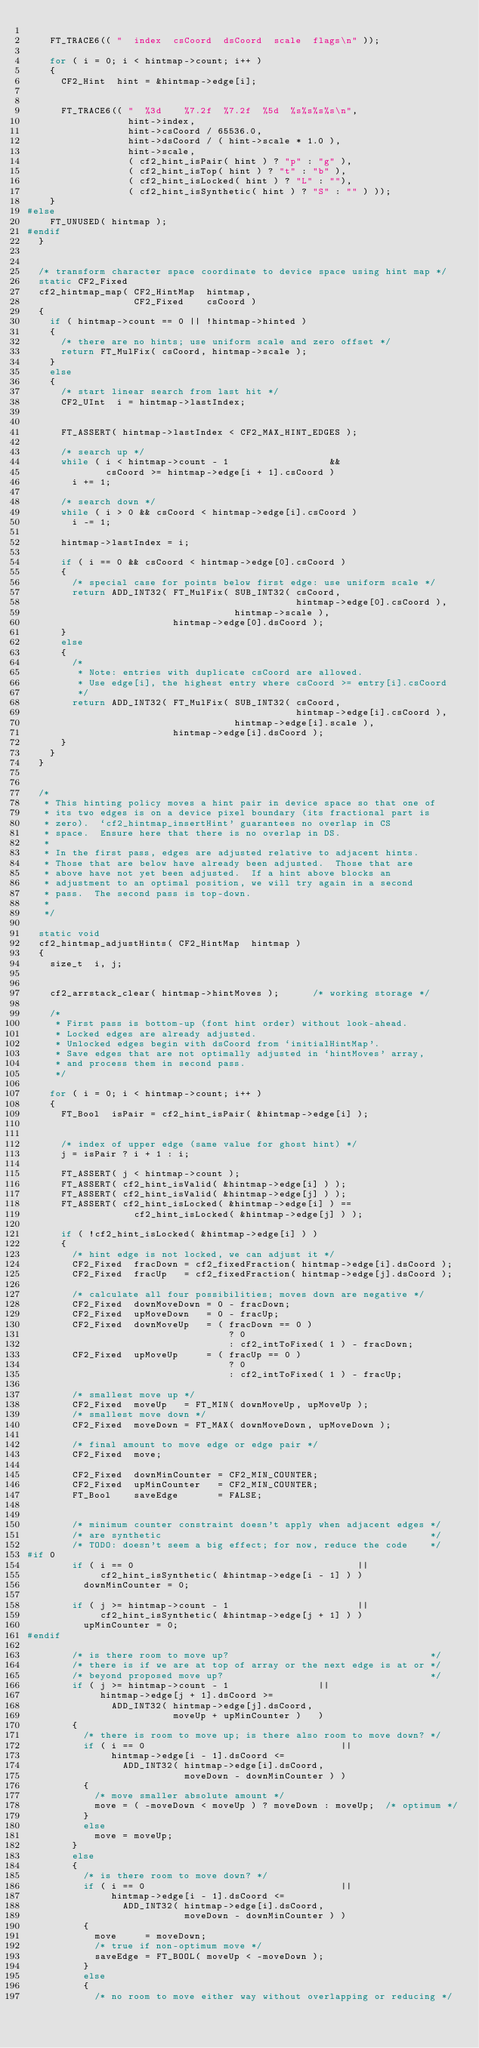<code> <loc_0><loc_0><loc_500><loc_500><_C_>
    FT_TRACE6(( "  index  csCoord  dsCoord  scale  flags\n" ));

    for ( i = 0; i < hintmap->count; i++ )
    {
      CF2_Hint  hint = &hintmap->edge[i];


      FT_TRACE6(( "  %3d    %7.2f  %7.2f  %5d  %s%s%s%s\n",
                  hint->index,
                  hint->csCoord / 65536.0,
                  hint->dsCoord / ( hint->scale * 1.0 ),
                  hint->scale,
                  ( cf2_hint_isPair( hint ) ? "p" : "g" ),
                  ( cf2_hint_isTop( hint ) ? "t" : "b" ),
                  ( cf2_hint_isLocked( hint ) ? "L" : ""),
                  ( cf2_hint_isSynthetic( hint ) ? "S" : "" ) ));
    }
#else
    FT_UNUSED( hintmap );
#endif
  }


  /* transform character space coordinate to device space using hint map */
  static CF2_Fixed
  cf2_hintmap_map( CF2_HintMap  hintmap,
                   CF2_Fixed    csCoord )
  {
    if ( hintmap->count == 0 || !hintmap->hinted )
    {
      /* there are no hints; use uniform scale and zero offset */
      return FT_MulFix( csCoord, hintmap->scale );
    }
    else
    {
      /* start linear search from last hit */
      CF2_UInt  i = hintmap->lastIndex;


      FT_ASSERT( hintmap->lastIndex < CF2_MAX_HINT_EDGES );

      /* search up */
      while ( i < hintmap->count - 1                  &&
              csCoord >= hintmap->edge[i + 1].csCoord )
        i += 1;

      /* search down */
      while ( i > 0 && csCoord < hintmap->edge[i].csCoord )
        i -= 1;

      hintmap->lastIndex = i;

      if ( i == 0 && csCoord < hintmap->edge[0].csCoord )
      {
        /* special case for points below first edge: use uniform scale */
        return ADD_INT32( FT_MulFix( SUB_INT32( csCoord,
                                                hintmap->edge[0].csCoord ),
                                     hintmap->scale ),
                          hintmap->edge[0].dsCoord );
      }
      else
      {
        /*
         * Note: entries with duplicate csCoord are allowed.
         * Use edge[i], the highest entry where csCoord >= entry[i].csCoord
         */
        return ADD_INT32( FT_MulFix( SUB_INT32( csCoord,
                                                hintmap->edge[i].csCoord ),
                                     hintmap->edge[i].scale ),
                          hintmap->edge[i].dsCoord );
      }
    }
  }


  /*
   * This hinting policy moves a hint pair in device space so that one of
   * its two edges is on a device pixel boundary (its fractional part is
   * zero).  `cf2_hintmap_insertHint' guarantees no overlap in CS
   * space.  Ensure here that there is no overlap in DS.
   *
   * In the first pass, edges are adjusted relative to adjacent hints.
   * Those that are below have already been adjusted.  Those that are
   * above have not yet been adjusted.  If a hint above blocks an
   * adjustment to an optimal position, we will try again in a second
   * pass.  The second pass is top-down.
   *
   */

  static void
  cf2_hintmap_adjustHints( CF2_HintMap  hintmap )
  {
    size_t  i, j;


    cf2_arrstack_clear( hintmap->hintMoves );      /* working storage */

    /*
     * First pass is bottom-up (font hint order) without look-ahead.
     * Locked edges are already adjusted.
     * Unlocked edges begin with dsCoord from `initialHintMap'.
     * Save edges that are not optimally adjusted in `hintMoves' array,
     * and process them in second pass.
     */

    for ( i = 0; i < hintmap->count; i++ )
    {
      FT_Bool  isPair = cf2_hint_isPair( &hintmap->edge[i] );


      /* index of upper edge (same value for ghost hint) */
      j = isPair ? i + 1 : i;

      FT_ASSERT( j < hintmap->count );
      FT_ASSERT( cf2_hint_isValid( &hintmap->edge[i] ) );
      FT_ASSERT( cf2_hint_isValid( &hintmap->edge[j] ) );
      FT_ASSERT( cf2_hint_isLocked( &hintmap->edge[i] ) ==
                   cf2_hint_isLocked( &hintmap->edge[j] ) );

      if ( !cf2_hint_isLocked( &hintmap->edge[i] ) )
      {
        /* hint edge is not locked, we can adjust it */
        CF2_Fixed  fracDown = cf2_fixedFraction( hintmap->edge[i].dsCoord );
        CF2_Fixed  fracUp   = cf2_fixedFraction( hintmap->edge[j].dsCoord );

        /* calculate all four possibilities; moves down are negative */
        CF2_Fixed  downMoveDown = 0 - fracDown;
        CF2_Fixed  upMoveDown   = 0 - fracUp;
        CF2_Fixed  downMoveUp   = ( fracDown == 0 )
                                    ? 0
                                    : cf2_intToFixed( 1 ) - fracDown;
        CF2_Fixed  upMoveUp     = ( fracUp == 0 )
                                    ? 0
                                    : cf2_intToFixed( 1 ) - fracUp;

        /* smallest move up */
        CF2_Fixed  moveUp   = FT_MIN( downMoveUp, upMoveUp );
        /* smallest move down */
        CF2_Fixed  moveDown = FT_MAX( downMoveDown, upMoveDown );

        /* final amount to move edge or edge pair */
        CF2_Fixed  move;

        CF2_Fixed  downMinCounter = CF2_MIN_COUNTER;
        CF2_Fixed  upMinCounter   = CF2_MIN_COUNTER;
        FT_Bool    saveEdge       = FALSE;


        /* minimum counter constraint doesn't apply when adjacent edges */
        /* are synthetic                                                */
        /* TODO: doesn't seem a big effect; for now, reduce the code    */
#if 0
        if ( i == 0                                        ||
             cf2_hint_isSynthetic( &hintmap->edge[i - 1] ) )
          downMinCounter = 0;

        if ( j >= hintmap->count - 1                       ||
             cf2_hint_isSynthetic( &hintmap->edge[j + 1] ) )
          upMinCounter = 0;
#endif

        /* is there room to move up?                                    */
        /* there is if we are at top of array or the next edge is at or */
        /* beyond proposed move up?                                     */
        if ( j >= hintmap->count - 1                ||
             hintmap->edge[j + 1].dsCoord >=
               ADD_INT32( hintmap->edge[j].dsCoord,
                          moveUp + upMinCounter )   )
        {
          /* there is room to move up; is there also room to move down? */
          if ( i == 0                                   ||
               hintmap->edge[i - 1].dsCoord <=
                 ADD_INT32( hintmap->edge[i].dsCoord,
                            moveDown - downMinCounter ) )
          {
            /* move smaller absolute amount */
            move = ( -moveDown < moveUp ) ? moveDown : moveUp;  /* optimum */
          }
          else
            move = moveUp;
        }
        else
        {
          /* is there room to move down? */
          if ( i == 0                                   ||
               hintmap->edge[i - 1].dsCoord <=
                 ADD_INT32( hintmap->edge[i].dsCoord,
                            moveDown - downMinCounter ) )
          {
            move     = moveDown;
            /* true if non-optimum move */
            saveEdge = FT_BOOL( moveUp < -moveDown );
          }
          else
          {
            /* no room to move either way without overlapping or reducing */</code> 